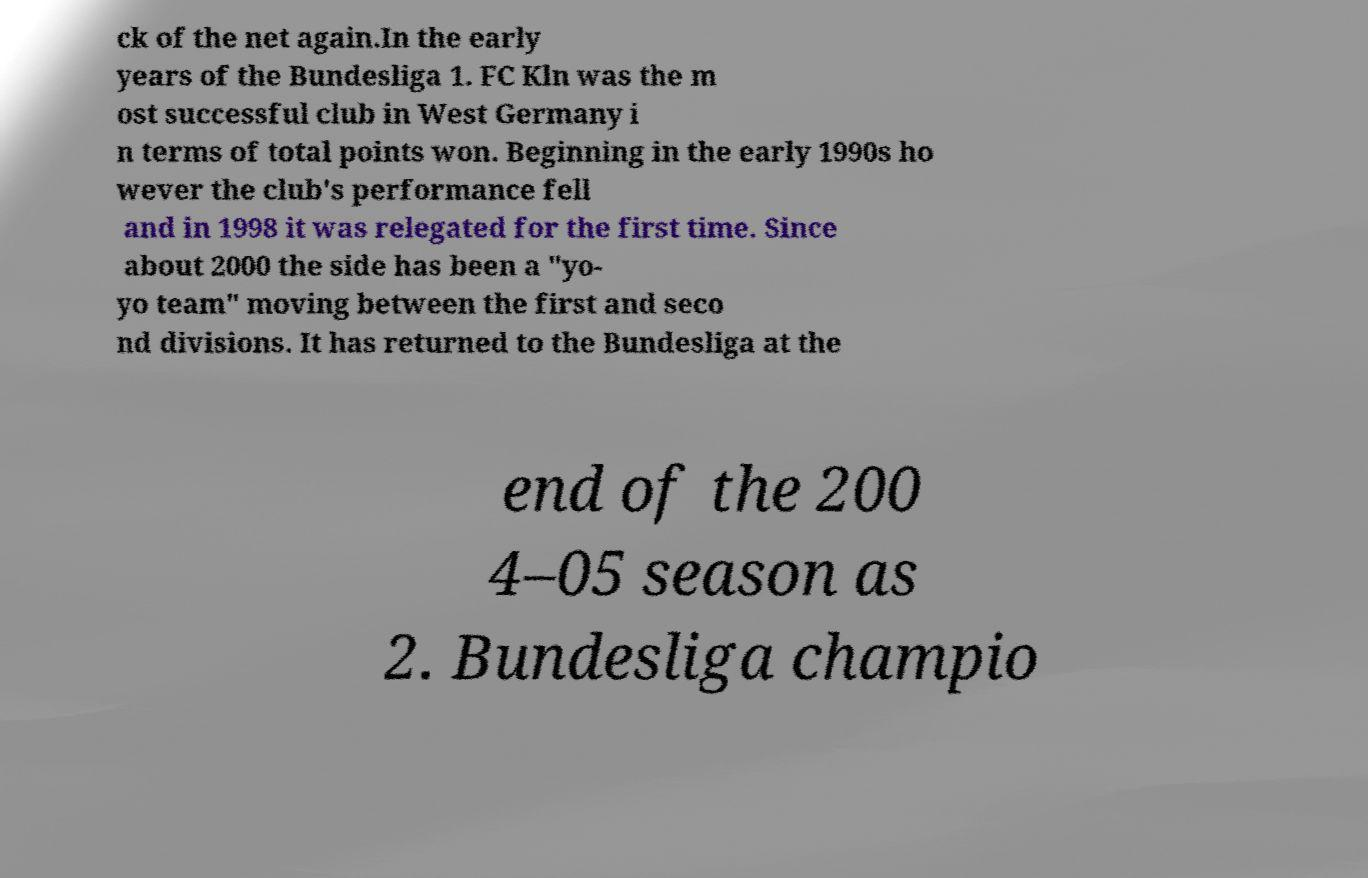Could you assist in decoding the text presented in this image and type it out clearly? ck of the net again.In the early years of the Bundesliga 1. FC Kln was the m ost successful club in West Germany i n terms of total points won. Beginning in the early 1990s ho wever the club's performance fell and in 1998 it was relegated for the first time. Since about 2000 the side has been a "yo- yo team" moving between the first and seco nd divisions. It has returned to the Bundesliga at the end of the 200 4–05 season as 2. Bundesliga champio 